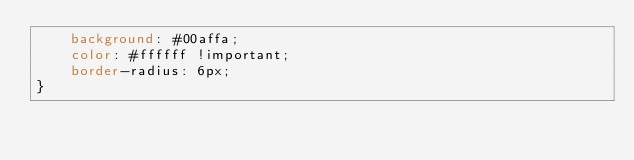Convert code to text. <code><loc_0><loc_0><loc_500><loc_500><_CSS_>    background: #00affa;
    color: #ffffff !important;
    border-radius: 6px;
}</code> 